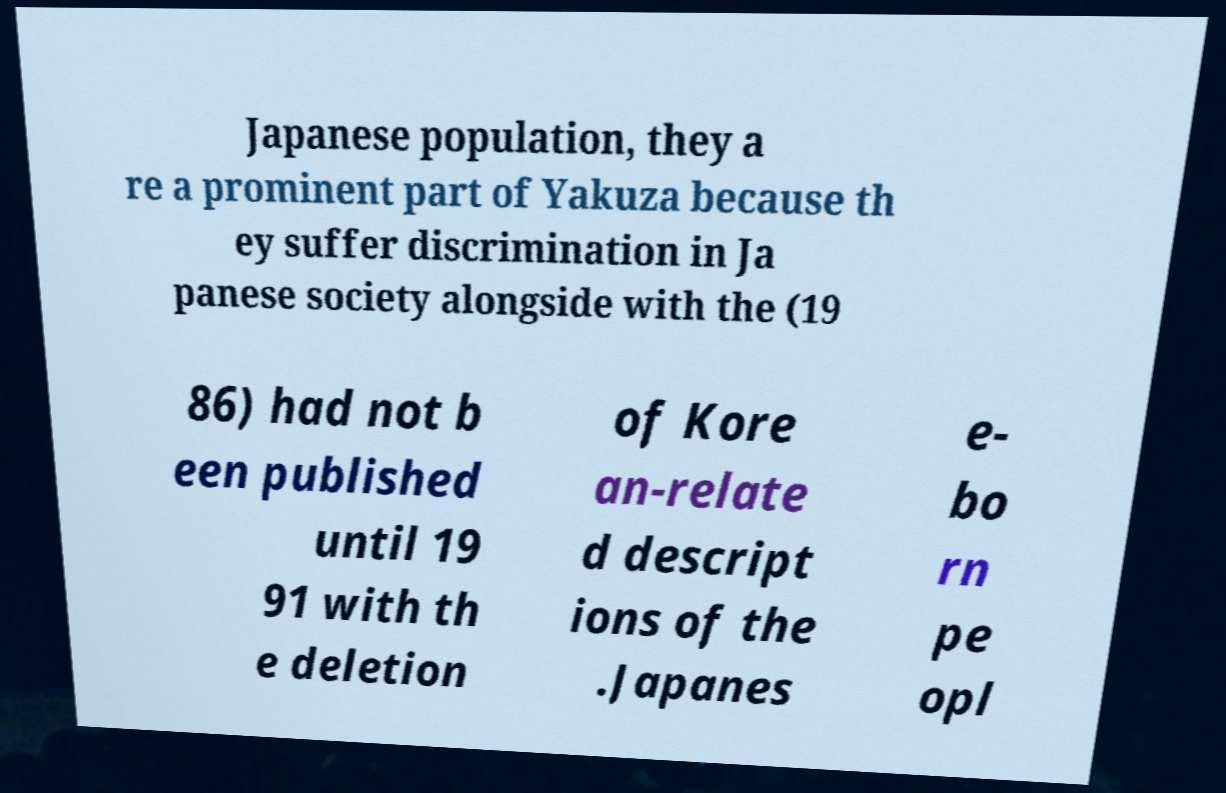Can you accurately transcribe the text from the provided image for me? Japanese population, they a re a prominent part of Yakuza because th ey suffer discrimination in Ja panese society alongside with the (19 86) had not b een published until 19 91 with th e deletion of Kore an-relate d descript ions of the .Japanes e- bo rn pe opl 